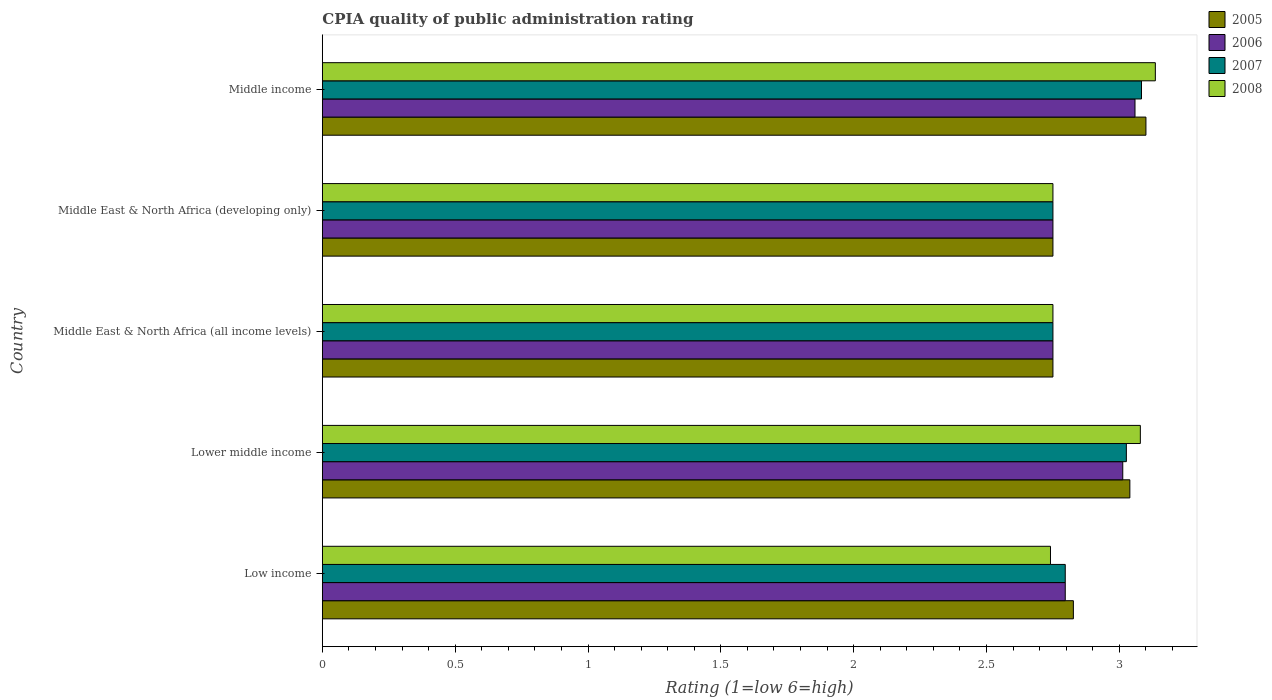How many different coloured bars are there?
Give a very brief answer. 4. How many groups of bars are there?
Your response must be concise. 5. Are the number of bars on each tick of the Y-axis equal?
Keep it short and to the point. Yes. What is the label of the 3rd group of bars from the top?
Offer a very short reply. Middle East & North Africa (all income levels). In how many cases, is the number of bars for a given country not equal to the number of legend labels?
Provide a short and direct response. 0. What is the CPIA rating in 2008 in Middle income?
Provide a succinct answer. 3.14. Across all countries, what is the minimum CPIA rating in 2008?
Offer a terse response. 2.74. In which country was the CPIA rating in 2006 maximum?
Give a very brief answer. Middle income. In which country was the CPIA rating in 2008 minimum?
Give a very brief answer. Low income. What is the total CPIA rating in 2007 in the graph?
Offer a terse response. 14.41. What is the difference between the CPIA rating in 2008 in Low income and that in Middle East & North Africa (developing only)?
Make the answer very short. -0.01. What is the difference between the CPIA rating in 2006 in Lower middle income and the CPIA rating in 2005 in Middle East & North Africa (developing only)?
Your answer should be compact. 0.26. What is the average CPIA rating in 2006 per country?
Ensure brevity in your answer.  2.87. What is the difference between the CPIA rating in 2008 and CPIA rating in 2006 in Lower middle income?
Your answer should be very brief. 0.07. What is the ratio of the CPIA rating in 2005 in Low income to that in Middle East & North Africa (all income levels)?
Make the answer very short. 1.03. Is the CPIA rating in 2008 in Middle East & North Africa (developing only) less than that in Middle income?
Your response must be concise. Yes. What is the difference between the highest and the second highest CPIA rating in 2005?
Ensure brevity in your answer.  0.06. What is the difference between the highest and the lowest CPIA rating in 2008?
Provide a succinct answer. 0.39. Is it the case that in every country, the sum of the CPIA rating in 2006 and CPIA rating in 2005 is greater than the CPIA rating in 2008?
Provide a succinct answer. Yes. Are all the bars in the graph horizontal?
Ensure brevity in your answer.  Yes. Does the graph contain grids?
Provide a short and direct response. No. Where does the legend appear in the graph?
Give a very brief answer. Top right. What is the title of the graph?
Provide a succinct answer. CPIA quality of public administration rating. What is the Rating (1=low 6=high) of 2005 in Low income?
Keep it short and to the point. 2.83. What is the Rating (1=low 6=high) of 2006 in Low income?
Provide a short and direct response. 2.8. What is the Rating (1=low 6=high) in 2007 in Low income?
Offer a very short reply. 2.8. What is the Rating (1=low 6=high) in 2008 in Low income?
Give a very brief answer. 2.74. What is the Rating (1=low 6=high) of 2005 in Lower middle income?
Your answer should be very brief. 3.04. What is the Rating (1=low 6=high) in 2006 in Lower middle income?
Your answer should be very brief. 3.01. What is the Rating (1=low 6=high) in 2007 in Lower middle income?
Provide a short and direct response. 3.03. What is the Rating (1=low 6=high) of 2008 in Lower middle income?
Keep it short and to the point. 3.08. What is the Rating (1=low 6=high) of 2005 in Middle East & North Africa (all income levels)?
Your answer should be very brief. 2.75. What is the Rating (1=low 6=high) in 2006 in Middle East & North Africa (all income levels)?
Offer a terse response. 2.75. What is the Rating (1=low 6=high) in 2007 in Middle East & North Africa (all income levels)?
Offer a terse response. 2.75. What is the Rating (1=low 6=high) of 2008 in Middle East & North Africa (all income levels)?
Ensure brevity in your answer.  2.75. What is the Rating (1=low 6=high) in 2005 in Middle East & North Africa (developing only)?
Provide a short and direct response. 2.75. What is the Rating (1=low 6=high) of 2006 in Middle East & North Africa (developing only)?
Give a very brief answer. 2.75. What is the Rating (1=low 6=high) of 2007 in Middle East & North Africa (developing only)?
Your answer should be compact. 2.75. What is the Rating (1=low 6=high) of 2008 in Middle East & North Africa (developing only)?
Your response must be concise. 2.75. What is the Rating (1=low 6=high) in 2005 in Middle income?
Provide a short and direct response. 3.1. What is the Rating (1=low 6=high) of 2006 in Middle income?
Keep it short and to the point. 3.06. What is the Rating (1=low 6=high) in 2007 in Middle income?
Your response must be concise. 3.08. What is the Rating (1=low 6=high) in 2008 in Middle income?
Your answer should be compact. 3.14. Across all countries, what is the maximum Rating (1=low 6=high) in 2006?
Provide a short and direct response. 3.06. Across all countries, what is the maximum Rating (1=low 6=high) in 2007?
Offer a very short reply. 3.08. Across all countries, what is the maximum Rating (1=low 6=high) in 2008?
Provide a succinct answer. 3.14. Across all countries, what is the minimum Rating (1=low 6=high) in 2005?
Provide a succinct answer. 2.75. Across all countries, what is the minimum Rating (1=low 6=high) of 2006?
Your response must be concise. 2.75. Across all countries, what is the minimum Rating (1=low 6=high) in 2007?
Your answer should be compact. 2.75. Across all countries, what is the minimum Rating (1=low 6=high) in 2008?
Keep it short and to the point. 2.74. What is the total Rating (1=low 6=high) of 2005 in the graph?
Your response must be concise. 14.47. What is the total Rating (1=low 6=high) of 2006 in the graph?
Your answer should be compact. 14.37. What is the total Rating (1=low 6=high) in 2007 in the graph?
Offer a terse response. 14.41. What is the total Rating (1=low 6=high) in 2008 in the graph?
Give a very brief answer. 14.46. What is the difference between the Rating (1=low 6=high) of 2005 in Low income and that in Lower middle income?
Give a very brief answer. -0.21. What is the difference between the Rating (1=low 6=high) in 2006 in Low income and that in Lower middle income?
Keep it short and to the point. -0.22. What is the difference between the Rating (1=low 6=high) of 2007 in Low income and that in Lower middle income?
Provide a succinct answer. -0.23. What is the difference between the Rating (1=low 6=high) of 2008 in Low income and that in Lower middle income?
Provide a succinct answer. -0.34. What is the difference between the Rating (1=low 6=high) in 2005 in Low income and that in Middle East & North Africa (all income levels)?
Offer a very short reply. 0.08. What is the difference between the Rating (1=low 6=high) in 2006 in Low income and that in Middle East & North Africa (all income levels)?
Offer a terse response. 0.05. What is the difference between the Rating (1=low 6=high) of 2007 in Low income and that in Middle East & North Africa (all income levels)?
Offer a very short reply. 0.05. What is the difference between the Rating (1=low 6=high) in 2008 in Low income and that in Middle East & North Africa (all income levels)?
Offer a very short reply. -0.01. What is the difference between the Rating (1=low 6=high) of 2005 in Low income and that in Middle East & North Africa (developing only)?
Make the answer very short. 0.08. What is the difference between the Rating (1=low 6=high) of 2006 in Low income and that in Middle East & North Africa (developing only)?
Offer a very short reply. 0.05. What is the difference between the Rating (1=low 6=high) of 2007 in Low income and that in Middle East & North Africa (developing only)?
Keep it short and to the point. 0.05. What is the difference between the Rating (1=low 6=high) of 2008 in Low income and that in Middle East & North Africa (developing only)?
Offer a very short reply. -0.01. What is the difference between the Rating (1=low 6=high) in 2005 in Low income and that in Middle income?
Provide a short and direct response. -0.27. What is the difference between the Rating (1=low 6=high) in 2006 in Low income and that in Middle income?
Provide a short and direct response. -0.26. What is the difference between the Rating (1=low 6=high) of 2007 in Low income and that in Middle income?
Ensure brevity in your answer.  -0.29. What is the difference between the Rating (1=low 6=high) of 2008 in Low income and that in Middle income?
Provide a succinct answer. -0.39. What is the difference between the Rating (1=low 6=high) of 2005 in Lower middle income and that in Middle East & North Africa (all income levels)?
Give a very brief answer. 0.29. What is the difference between the Rating (1=low 6=high) of 2006 in Lower middle income and that in Middle East & North Africa (all income levels)?
Give a very brief answer. 0.26. What is the difference between the Rating (1=low 6=high) in 2007 in Lower middle income and that in Middle East & North Africa (all income levels)?
Your answer should be very brief. 0.28. What is the difference between the Rating (1=low 6=high) in 2008 in Lower middle income and that in Middle East & North Africa (all income levels)?
Give a very brief answer. 0.33. What is the difference between the Rating (1=low 6=high) of 2005 in Lower middle income and that in Middle East & North Africa (developing only)?
Your response must be concise. 0.29. What is the difference between the Rating (1=low 6=high) of 2006 in Lower middle income and that in Middle East & North Africa (developing only)?
Offer a very short reply. 0.26. What is the difference between the Rating (1=low 6=high) of 2007 in Lower middle income and that in Middle East & North Africa (developing only)?
Give a very brief answer. 0.28. What is the difference between the Rating (1=low 6=high) of 2008 in Lower middle income and that in Middle East & North Africa (developing only)?
Your response must be concise. 0.33. What is the difference between the Rating (1=low 6=high) in 2005 in Lower middle income and that in Middle income?
Keep it short and to the point. -0.06. What is the difference between the Rating (1=low 6=high) in 2006 in Lower middle income and that in Middle income?
Give a very brief answer. -0.05. What is the difference between the Rating (1=low 6=high) in 2007 in Lower middle income and that in Middle income?
Ensure brevity in your answer.  -0.06. What is the difference between the Rating (1=low 6=high) in 2008 in Lower middle income and that in Middle income?
Give a very brief answer. -0.06. What is the difference between the Rating (1=low 6=high) in 2005 in Middle East & North Africa (all income levels) and that in Middle East & North Africa (developing only)?
Make the answer very short. 0. What is the difference between the Rating (1=low 6=high) of 2007 in Middle East & North Africa (all income levels) and that in Middle East & North Africa (developing only)?
Offer a very short reply. 0. What is the difference between the Rating (1=low 6=high) of 2005 in Middle East & North Africa (all income levels) and that in Middle income?
Ensure brevity in your answer.  -0.35. What is the difference between the Rating (1=low 6=high) in 2006 in Middle East & North Africa (all income levels) and that in Middle income?
Ensure brevity in your answer.  -0.31. What is the difference between the Rating (1=low 6=high) of 2007 in Middle East & North Africa (all income levels) and that in Middle income?
Give a very brief answer. -0.33. What is the difference between the Rating (1=low 6=high) in 2008 in Middle East & North Africa (all income levels) and that in Middle income?
Your response must be concise. -0.39. What is the difference between the Rating (1=low 6=high) in 2005 in Middle East & North Africa (developing only) and that in Middle income?
Keep it short and to the point. -0.35. What is the difference between the Rating (1=low 6=high) of 2006 in Middle East & North Africa (developing only) and that in Middle income?
Your answer should be very brief. -0.31. What is the difference between the Rating (1=low 6=high) of 2007 in Middle East & North Africa (developing only) and that in Middle income?
Your answer should be very brief. -0.33. What is the difference between the Rating (1=low 6=high) of 2008 in Middle East & North Africa (developing only) and that in Middle income?
Ensure brevity in your answer.  -0.39. What is the difference between the Rating (1=low 6=high) of 2005 in Low income and the Rating (1=low 6=high) of 2006 in Lower middle income?
Give a very brief answer. -0.19. What is the difference between the Rating (1=low 6=high) of 2005 in Low income and the Rating (1=low 6=high) of 2007 in Lower middle income?
Keep it short and to the point. -0.2. What is the difference between the Rating (1=low 6=high) of 2005 in Low income and the Rating (1=low 6=high) of 2008 in Lower middle income?
Provide a short and direct response. -0.25. What is the difference between the Rating (1=low 6=high) in 2006 in Low income and the Rating (1=low 6=high) in 2007 in Lower middle income?
Give a very brief answer. -0.23. What is the difference between the Rating (1=low 6=high) in 2006 in Low income and the Rating (1=low 6=high) in 2008 in Lower middle income?
Provide a short and direct response. -0.28. What is the difference between the Rating (1=low 6=high) in 2007 in Low income and the Rating (1=low 6=high) in 2008 in Lower middle income?
Your answer should be very brief. -0.28. What is the difference between the Rating (1=low 6=high) of 2005 in Low income and the Rating (1=low 6=high) of 2006 in Middle East & North Africa (all income levels)?
Keep it short and to the point. 0.08. What is the difference between the Rating (1=low 6=high) in 2005 in Low income and the Rating (1=low 6=high) in 2007 in Middle East & North Africa (all income levels)?
Offer a very short reply. 0.08. What is the difference between the Rating (1=low 6=high) in 2005 in Low income and the Rating (1=low 6=high) in 2008 in Middle East & North Africa (all income levels)?
Keep it short and to the point. 0.08. What is the difference between the Rating (1=low 6=high) of 2006 in Low income and the Rating (1=low 6=high) of 2007 in Middle East & North Africa (all income levels)?
Keep it short and to the point. 0.05. What is the difference between the Rating (1=low 6=high) in 2006 in Low income and the Rating (1=low 6=high) in 2008 in Middle East & North Africa (all income levels)?
Offer a terse response. 0.05. What is the difference between the Rating (1=low 6=high) of 2007 in Low income and the Rating (1=low 6=high) of 2008 in Middle East & North Africa (all income levels)?
Make the answer very short. 0.05. What is the difference between the Rating (1=low 6=high) of 2005 in Low income and the Rating (1=low 6=high) of 2006 in Middle East & North Africa (developing only)?
Your answer should be very brief. 0.08. What is the difference between the Rating (1=low 6=high) of 2005 in Low income and the Rating (1=low 6=high) of 2007 in Middle East & North Africa (developing only)?
Ensure brevity in your answer.  0.08. What is the difference between the Rating (1=low 6=high) of 2005 in Low income and the Rating (1=low 6=high) of 2008 in Middle East & North Africa (developing only)?
Your response must be concise. 0.08. What is the difference between the Rating (1=low 6=high) in 2006 in Low income and the Rating (1=low 6=high) in 2007 in Middle East & North Africa (developing only)?
Give a very brief answer. 0.05. What is the difference between the Rating (1=low 6=high) of 2006 in Low income and the Rating (1=low 6=high) of 2008 in Middle East & North Africa (developing only)?
Offer a very short reply. 0.05. What is the difference between the Rating (1=low 6=high) in 2007 in Low income and the Rating (1=low 6=high) in 2008 in Middle East & North Africa (developing only)?
Give a very brief answer. 0.05. What is the difference between the Rating (1=low 6=high) in 2005 in Low income and the Rating (1=low 6=high) in 2006 in Middle income?
Provide a succinct answer. -0.23. What is the difference between the Rating (1=low 6=high) of 2005 in Low income and the Rating (1=low 6=high) of 2007 in Middle income?
Provide a short and direct response. -0.26. What is the difference between the Rating (1=low 6=high) in 2005 in Low income and the Rating (1=low 6=high) in 2008 in Middle income?
Your answer should be very brief. -0.31. What is the difference between the Rating (1=low 6=high) in 2006 in Low income and the Rating (1=low 6=high) in 2007 in Middle income?
Your response must be concise. -0.29. What is the difference between the Rating (1=low 6=high) in 2006 in Low income and the Rating (1=low 6=high) in 2008 in Middle income?
Your answer should be very brief. -0.34. What is the difference between the Rating (1=low 6=high) in 2007 in Low income and the Rating (1=low 6=high) in 2008 in Middle income?
Your answer should be very brief. -0.34. What is the difference between the Rating (1=low 6=high) of 2005 in Lower middle income and the Rating (1=low 6=high) of 2006 in Middle East & North Africa (all income levels)?
Your answer should be very brief. 0.29. What is the difference between the Rating (1=low 6=high) in 2005 in Lower middle income and the Rating (1=low 6=high) in 2007 in Middle East & North Africa (all income levels)?
Give a very brief answer. 0.29. What is the difference between the Rating (1=low 6=high) in 2005 in Lower middle income and the Rating (1=low 6=high) in 2008 in Middle East & North Africa (all income levels)?
Your answer should be compact. 0.29. What is the difference between the Rating (1=low 6=high) of 2006 in Lower middle income and the Rating (1=low 6=high) of 2007 in Middle East & North Africa (all income levels)?
Ensure brevity in your answer.  0.26. What is the difference between the Rating (1=low 6=high) in 2006 in Lower middle income and the Rating (1=low 6=high) in 2008 in Middle East & North Africa (all income levels)?
Make the answer very short. 0.26. What is the difference between the Rating (1=low 6=high) in 2007 in Lower middle income and the Rating (1=low 6=high) in 2008 in Middle East & North Africa (all income levels)?
Your answer should be very brief. 0.28. What is the difference between the Rating (1=low 6=high) of 2005 in Lower middle income and the Rating (1=low 6=high) of 2006 in Middle East & North Africa (developing only)?
Offer a very short reply. 0.29. What is the difference between the Rating (1=low 6=high) in 2005 in Lower middle income and the Rating (1=low 6=high) in 2007 in Middle East & North Africa (developing only)?
Offer a very short reply. 0.29. What is the difference between the Rating (1=low 6=high) of 2005 in Lower middle income and the Rating (1=low 6=high) of 2008 in Middle East & North Africa (developing only)?
Ensure brevity in your answer.  0.29. What is the difference between the Rating (1=low 6=high) of 2006 in Lower middle income and the Rating (1=low 6=high) of 2007 in Middle East & North Africa (developing only)?
Offer a terse response. 0.26. What is the difference between the Rating (1=low 6=high) in 2006 in Lower middle income and the Rating (1=low 6=high) in 2008 in Middle East & North Africa (developing only)?
Offer a very short reply. 0.26. What is the difference between the Rating (1=low 6=high) in 2007 in Lower middle income and the Rating (1=low 6=high) in 2008 in Middle East & North Africa (developing only)?
Your answer should be compact. 0.28. What is the difference between the Rating (1=low 6=high) in 2005 in Lower middle income and the Rating (1=low 6=high) in 2006 in Middle income?
Keep it short and to the point. -0.02. What is the difference between the Rating (1=low 6=high) of 2005 in Lower middle income and the Rating (1=low 6=high) of 2007 in Middle income?
Ensure brevity in your answer.  -0.04. What is the difference between the Rating (1=low 6=high) in 2005 in Lower middle income and the Rating (1=low 6=high) in 2008 in Middle income?
Offer a terse response. -0.1. What is the difference between the Rating (1=low 6=high) in 2006 in Lower middle income and the Rating (1=low 6=high) in 2007 in Middle income?
Give a very brief answer. -0.07. What is the difference between the Rating (1=low 6=high) of 2006 in Lower middle income and the Rating (1=low 6=high) of 2008 in Middle income?
Give a very brief answer. -0.12. What is the difference between the Rating (1=low 6=high) in 2007 in Lower middle income and the Rating (1=low 6=high) in 2008 in Middle income?
Ensure brevity in your answer.  -0.11. What is the difference between the Rating (1=low 6=high) of 2005 in Middle East & North Africa (all income levels) and the Rating (1=low 6=high) of 2007 in Middle East & North Africa (developing only)?
Provide a succinct answer. 0. What is the difference between the Rating (1=low 6=high) in 2005 in Middle East & North Africa (all income levels) and the Rating (1=low 6=high) in 2006 in Middle income?
Give a very brief answer. -0.31. What is the difference between the Rating (1=low 6=high) in 2005 in Middle East & North Africa (all income levels) and the Rating (1=low 6=high) in 2008 in Middle income?
Offer a terse response. -0.39. What is the difference between the Rating (1=low 6=high) in 2006 in Middle East & North Africa (all income levels) and the Rating (1=low 6=high) in 2007 in Middle income?
Keep it short and to the point. -0.33. What is the difference between the Rating (1=low 6=high) in 2006 in Middle East & North Africa (all income levels) and the Rating (1=low 6=high) in 2008 in Middle income?
Ensure brevity in your answer.  -0.39. What is the difference between the Rating (1=low 6=high) in 2007 in Middle East & North Africa (all income levels) and the Rating (1=low 6=high) in 2008 in Middle income?
Your answer should be compact. -0.39. What is the difference between the Rating (1=low 6=high) in 2005 in Middle East & North Africa (developing only) and the Rating (1=low 6=high) in 2006 in Middle income?
Provide a short and direct response. -0.31. What is the difference between the Rating (1=low 6=high) in 2005 in Middle East & North Africa (developing only) and the Rating (1=low 6=high) in 2007 in Middle income?
Your answer should be very brief. -0.33. What is the difference between the Rating (1=low 6=high) in 2005 in Middle East & North Africa (developing only) and the Rating (1=low 6=high) in 2008 in Middle income?
Keep it short and to the point. -0.39. What is the difference between the Rating (1=low 6=high) of 2006 in Middle East & North Africa (developing only) and the Rating (1=low 6=high) of 2007 in Middle income?
Offer a terse response. -0.33. What is the difference between the Rating (1=low 6=high) of 2006 in Middle East & North Africa (developing only) and the Rating (1=low 6=high) of 2008 in Middle income?
Your response must be concise. -0.39. What is the difference between the Rating (1=low 6=high) of 2007 in Middle East & North Africa (developing only) and the Rating (1=low 6=high) of 2008 in Middle income?
Give a very brief answer. -0.39. What is the average Rating (1=low 6=high) in 2005 per country?
Provide a succinct answer. 2.89. What is the average Rating (1=low 6=high) in 2006 per country?
Offer a very short reply. 2.87. What is the average Rating (1=low 6=high) of 2007 per country?
Provide a succinct answer. 2.88. What is the average Rating (1=low 6=high) of 2008 per country?
Ensure brevity in your answer.  2.89. What is the difference between the Rating (1=low 6=high) in 2005 and Rating (1=low 6=high) in 2006 in Low income?
Keep it short and to the point. 0.03. What is the difference between the Rating (1=low 6=high) in 2005 and Rating (1=low 6=high) in 2007 in Low income?
Give a very brief answer. 0.03. What is the difference between the Rating (1=low 6=high) of 2005 and Rating (1=low 6=high) of 2008 in Low income?
Your answer should be very brief. 0.09. What is the difference between the Rating (1=low 6=high) of 2006 and Rating (1=low 6=high) of 2007 in Low income?
Provide a short and direct response. 0. What is the difference between the Rating (1=low 6=high) in 2006 and Rating (1=low 6=high) in 2008 in Low income?
Give a very brief answer. 0.06. What is the difference between the Rating (1=low 6=high) in 2007 and Rating (1=low 6=high) in 2008 in Low income?
Offer a terse response. 0.06. What is the difference between the Rating (1=low 6=high) of 2005 and Rating (1=low 6=high) of 2006 in Lower middle income?
Offer a terse response. 0.03. What is the difference between the Rating (1=low 6=high) of 2005 and Rating (1=low 6=high) of 2007 in Lower middle income?
Give a very brief answer. 0.01. What is the difference between the Rating (1=low 6=high) of 2005 and Rating (1=low 6=high) of 2008 in Lower middle income?
Make the answer very short. -0.04. What is the difference between the Rating (1=low 6=high) of 2006 and Rating (1=low 6=high) of 2007 in Lower middle income?
Your answer should be compact. -0.01. What is the difference between the Rating (1=low 6=high) of 2006 and Rating (1=low 6=high) of 2008 in Lower middle income?
Your answer should be compact. -0.07. What is the difference between the Rating (1=low 6=high) in 2007 and Rating (1=low 6=high) in 2008 in Lower middle income?
Offer a very short reply. -0.05. What is the difference between the Rating (1=low 6=high) of 2005 and Rating (1=low 6=high) of 2006 in Middle East & North Africa (all income levels)?
Offer a terse response. 0. What is the difference between the Rating (1=low 6=high) of 2006 and Rating (1=low 6=high) of 2007 in Middle East & North Africa (all income levels)?
Offer a terse response. 0. What is the difference between the Rating (1=low 6=high) in 2005 and Rating (1=low 6=high) in 2006 in Middle East & North Africa (developing only)?
Make the answer very short. 0. What is the difference between the Rating (1=low 6=high) of 2005 and Rating (1=low 6=high) of 2008 in Middle East & North Africa (developing only)?
Give a very brief answer. 0. What is the difference between the Rating (1=low 6=high) in 2006 and Rating (1=low 6=high) in 2007 in Middle East & North Africa (developing only)?
Keep it short and to the point. 0. What is the difference between the Rating (1=low 6=high) in 2006 and Rating (1=low 6=high) in 2008 in Middle East & North Africa (developing only)?
Your response must be concise. 0. What is the difference between the Rating (1=low 6=high) in 2007 and Rating (1=low 6=high) in 2008 in Middle East & North Africa (developing only)?
Your answer should be compact. 0. What is the difference between the Rating (1=low 6=high) of 2005 and Rating (1=low 6=high) of 2006 in Middle income?
Your answer should be compact. 0.04. What is the difference between the Rating (1=low 6=high) in 2005 and Rating (1=low 6=high) in 2007 in Middle income?
Give a very brief answer. 0.02. What is the difference between the Rating (1=low 6=high) of 2005 and Rating (1=low 6=high) of 2008 in Middle income?
Ensure brevity in your answer.  -0.04. What is the difference between the Rating (1=low 6=high) of 2006 and Rating (1=low 6=high) of 2007 in Middle income?
Give a very brief answer. -0.02. What is the difference between the Rating (1=low 6=high) in 2006 and Rating (1=low 6=high) in 2008 in Middle income?
Your response must be concise. -0.08. What is the difference between the Rating (1=low 6=high) in 2007 and Rating (1=low 6=high) in 2008 in Middle income?
Offer a terse response. -0.05. What is the ratio of the Rating (1=low 6=high) of 2005 in Low income to that in Lower middle income?
Offer a terse response. 0.93. What is the ratio of the Rating (1=low 6=high) in 2006 in Low income to that in Lower middle income?
Offer a terse response. 0.93. What is the ratio of the Rating (1=low 6=high) of 2007 in Low income to that in Lower middle income?
Your answer should be very brief. 0.92. What is the ratio of the Rating (1=low 6=high) of 2008 in Low income to that in Lower middle income?
Ensure brevity in your answer.  0.89. What is the ratio of the Rating (1=low 6=high) in 2005 in Low income to that in Middle East & North Africa (all income levels)?
Keep it short and to the point. 1.03. What is the ratio of the Rating (1=low 6=high) in 2006 in Low income to that in Middle East & North Africa (all income levels)?
Provide a succinct answer. 1.02. What is the ratio of the Rating (1=low 6=high) in 2007 in Low income to that in Middle East & North Africa (all income levels)?
Your answer should be very brief. 1.02. What is the ratio of the Rating (1=low 6=high) of 2008 in Low income to that in Middle East & North Africa (all income levels)?
Offer a very short reply. 1. What is the ratio of the Rating (1=low 6=high) of 2005 in Low income to that in Middle East & North Africa (developing only)?
Make the answer very short. 1.03. What is the ratio of the Rating (1=low 6=high) in 2006 in Low income to that in Middle East & North Africa (developing only)?
Keep it short and to the point. 1.02. What is the ratio of the Rating (1=low 6=high) in 2007 in Low income to that in Middle East & North Africa (developing only)?
Keep it short and to the point. 1.02. What is the ratio of the Rating (1=low 6=high) in 2008 in Low income to that in Middle East & North Africa (developing only)?
Offer a terse response. 1. What is the ratio of the Rating (1=low 6=high) in 2005 in Low income to that in Middle income?
Give a very brief answer. 0.91. What is the ratio of the Rating (1=low 6=high) of 2006 in Low income to that in Middle income?
Your response must be concise. 0.91. What is the ratio of the Rating (1=low 6=high) in 2007 in Low income to that in Middle income?
Your response must be concise. 0.91. What is the ratio of the Rating (1=low 6=high) in 2008 in Low income to that in Middle income?
Ensure brevity in your answer.  0.87. What is the ratio of the Rating (1=low 6=high) of 2005 in Lower middle income to that in Middle East & North Africa (all income levels)?
Keep it short and to the point. 1.11. What is the ratio of the Rating (1=low 6=high) in 2006 in Lower middle income to that in Middle East & North Africa (all income levels)?
Your response must be concise. 1.1. What is the ratio of the Rating (1=low 6=high) in 2007 in Lower middle income to that in Middle East & North Africa (all income levels)?
Ensure brevity in your answer.  1.1. What is the ratio of the Rating (1=low 6=high) of 2008 in Lower middle income to that in Middle East & North Africa (all income levels)?
Keep it short and to the point. 1.12. What is the ratio of the Rating (1=low 6=high) in 2005 in Lower middle income to that in Middle East & North Africa (developing only)?
Make the answer very short. 1.11. What is the ratio of the Rating (1=low 6=high) of 2006 in Lower middle income to that in Middle East & North Africa (developing only)?
Provide a succinct answer. 1.1. What is the ratio of the Rating (1=low 6=high) of 2007 in Lower middle income to that in Middle East & North Africa (developing only)?
Your answer should be compact. 1.1. What is the ratio of the Rating (1=low 6=high) of 2008 in Lower middle income to that in Middle East & North Africa (developing only)?
Your answer should be compact. 1.12. What is the ratio of the Rating (1=low 6=high) of 2005 in Lower middle income to that in Middle income?
Offer a terse response. 0.98. What is the ratio of the Rating (1=low 6=high) of 2006 in Lower middle income to that in Middle income?
Offer a terse response. 0.98. What is the ratio of the Rating (1=low 6=high) of 2007 in Lower middle income to that in Middle income?
Provide a short and direct response. 0.98. What is the ratio of the Rating (1=low 6=high) of 2006 in Middle East & North Africa (all income levels) to that in Middle East & North Africa (developing only)?
Offer a very short reply. 1. What is the ratio of the Rating (1=low 6=high) in 2005 in Middle East & North Africa (all income levels) to that in Middle income?
Your answer should be very brief. 0.89. What is the ratio of the Rating (1=low 6=high) of 2006 in Middle East & North Africa (all income levels) to that in Middle income?
Your answer should be compact. 0.9. What is the ratio of the Rating (1=low 6=high) in 2007 in Middle East & North Africa (all income levels) to that in Middle income?
Offer a very short reply. 0.89. What is the ratio of the Rating (1=low 6=high) in 2008 in Middle East & North Africa (all income levels) to that in Middle income?
Provide a short and direct response. 0.88. What is the ratio of the Rating (1=low 6=high) in 2005 in Middle East & North Africa (developing only) to that in Middle income?
Your response must be concise. 0.89. What is the ratio of the Rating (1=low 6=high) of 2006 in Middle East & North Africa (developing only) to that in Middle income?
Make the answer very short. 0.9. What is the ratio of the Rating (1=low 6=high) in 2007 in Middle East & North Africa (developing only) to that in Middle income?
Make the answer very short. 0.89. What is the ratio of the Rating (1=low 6=high) of 2008 in Middle East & North Africa (developing only) to that in Middle income?
Provide a short and direct response. 0.88. What is the difference between the highest and the second highest Rating (1=low 6=high) of 2005?
Provide a succinct answer. 0.06. What is the difference between the highest and the second highest Rating (1=low 6=high) of 2006?
Keep it short and to the point. 0.05. What is the difference between the highest and the second highest Rating (1=low 6=high) of 2007?
Provide a short and direct response. 0.06. What is the difference between the highest and the second highest Rating (1=low 6=high) of 2008?
Keep it short and to the point. 0.06. What is the difference between the highest and the lowest Rating (1=low 6=high) of 2006?
Keep it short and to the point. 0.31. What is the difference between the highest and the lowest Rating (1=low 6=high) in 2007?
Provide a succinct answer. 0.33. What is the difference between the highest and the lowest Rating (1=low 6=high) in 2008?
Ensure brevity in your answer.  0.39. 